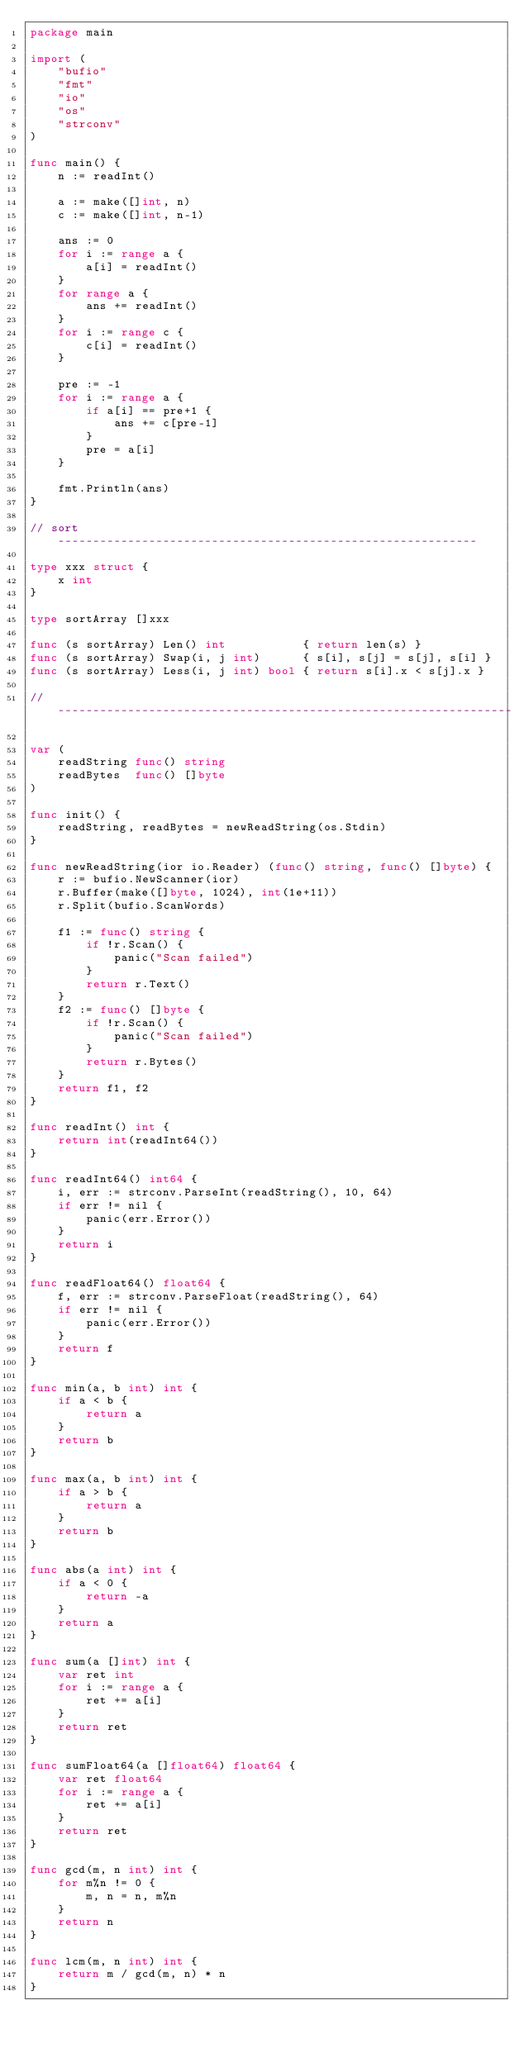Convert code to text. <code><loc_0><loc_0><loc_500><loc_500><_Go_>package main

import (
	"bufio"
	"fmt"
	"io"
	"os"
	"strconv"
)

func main() {
	n := readInt()

	a := make([]int, n)
	c := make([]int, n-1)

	ans := 0
	for i := range a {
		a[i] = readInt()
	}
	for range a {
		ans += readInt()
	}
	for i := range c {
		c[i] = readInt()
	}

	pre := -1
	for i := range a {
		if a[i] == pre+1 {
			ans += c[pre-1]
		}
		pre = a[i]
	}

	fmt.Println(ans)
}

// sort ------------------------------------------------------------

type xxx struct {
	x int
}

type sortArray []xxx

func (s sortArray) Len() int           { return len(s) }
func (s sortArray) Swap(i, j int)      { s[i], s[j] = s[j], s[i] }
func (s sortArray) Less(i, j int) bool { return s[i].x < s[j].x }

// -----------------------------------------------------------------

var (
	readString func() string
	readBytes  func() []byte
)

func init() {
	readString, readBytes = newReadString(os.Stdin)
}

func newReadString(ior io.Reader) (func() string, func() []byte) {
	r := bufio.NewScanner(ior)
	r.Buffer(make([]byte, 1024), int(1e+11))
	r.Split(bufio.ScanWords)

	f1 := func() string {
		if !r.Scan() {
			panic("Scan failed")
		}
		return r.Text()
	}
	f2 := func() []byte {
		if !r.Scan() {
			panic("Scan failed")
		}
		return r.Bytes()
	}
	return f1, f2
}

func readInt() int {
	return int(readInt64())
}

func readInt64() int64 {
	i, err := strconv.ParseInt(readString(), 10, 64)
	if err != nil {
		panic(err.Error())
	}
	return i
}

func readFloat64() float64 {
	f, err := strconv.ParseFloat(readString(), 64)
	if err != nil {
		panic(err.Error())
	}
	return f
}

func min(a, b int) int {
	if a < b {
		return a
	}
	return b
}

func max(a, b int) int {
	if a > b {
		return a
	}
	return b
}

func abs(a int) int {
	if a < 0 {
		return -a
	}
	return a
}

func sum(a []int) int {
	var ret int
	for i := range a {
		ret += a[i]
	}
	return ret
}

func sumFloat64(a []float64) float64 {
	var ret float64
	for i := range a {
		ret += a[i]
	}
	return ret
}

func gcd(m, n int) int {
	for m%n != 0 {
		m, n = n, m%n
	}
	return n
}

func lcm(m, n int) int {
	return m / gcd(m, n) * n
}
</code> 